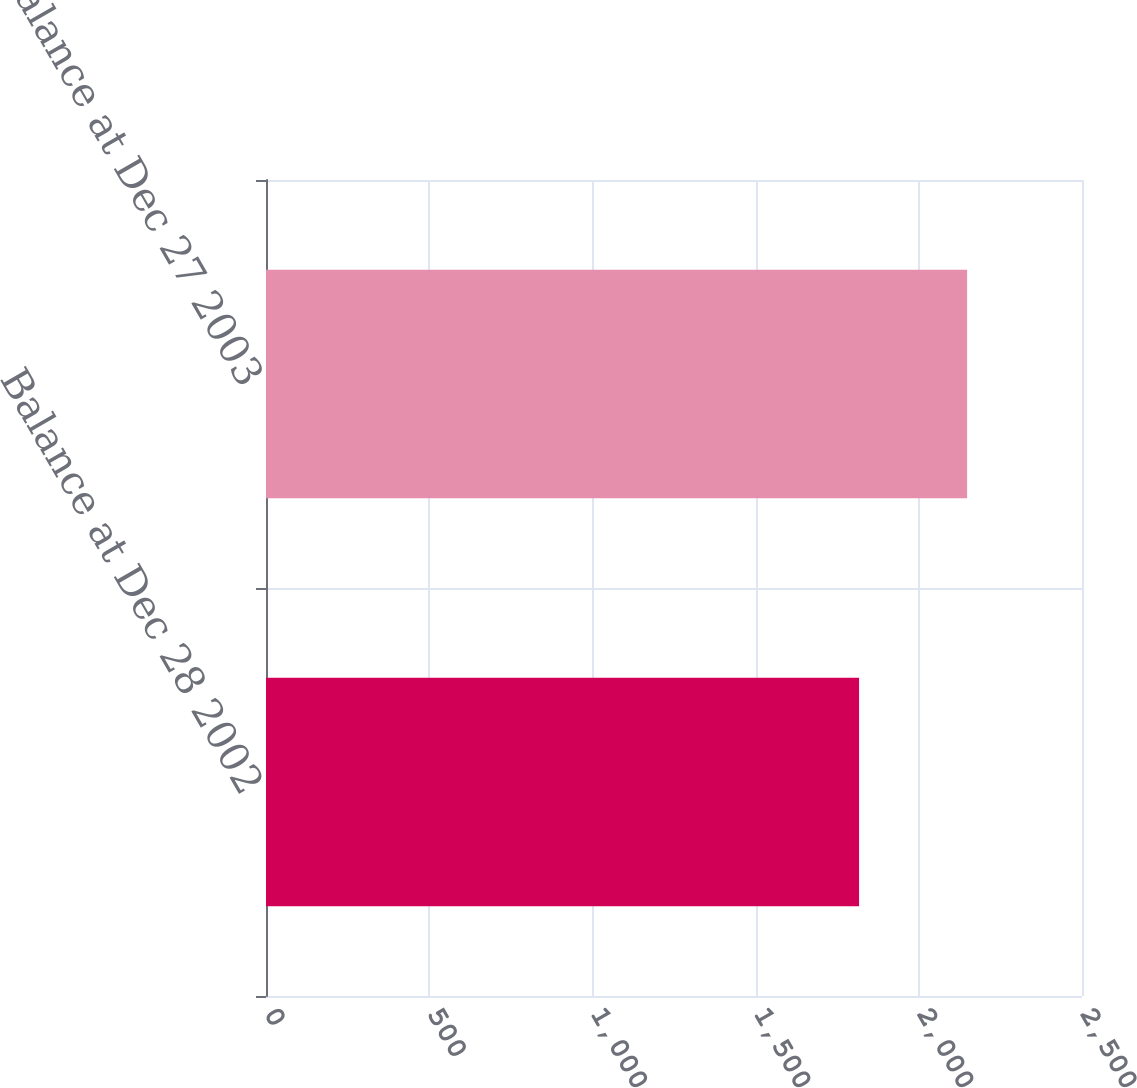Convert chart to OTSL. <chart><loc_0><loc_0><loc_500><loc_500><bar_chart><fcel>Balance at Dec 28 2002<fcel>Balance at Dec 27 2003<nl><fcel>1817<fcel>2148<nl></chart> 